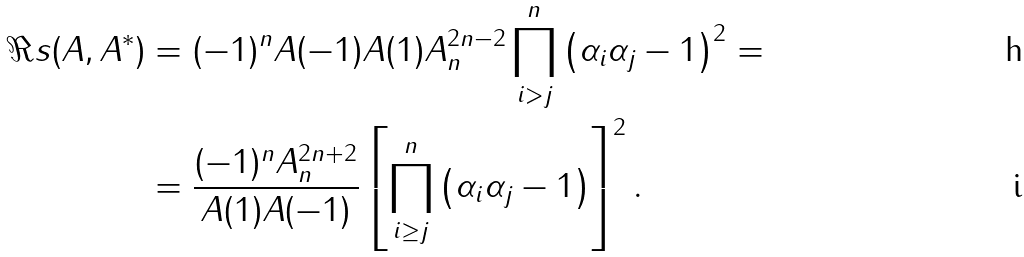<formula> <loc_0><loc_0><loc_500><loc_500>\Re s ( A , A ^ { * } ) & = ( - 1 ) ^ { n } A ( - 1 ) A ( 1 ) A _ { n } ^ { 2 n - 2 } \prod _ { i > j } ^ { n } \left ( \alpha _ { i } \alpha _ { j } - 1 \right ) ^ { 2 } = \\ & = \frac { ( - 1 ) ^ { n } A _ { n } ^ { 2 n + 2 } } { A ( 1 ) A ( - 1 ) } \left [ \prod _ { i \geq j } ^ { n } \left ( \alpha _ { i } \alpha _ { j } - 1 \right ) \right ] ^ { 2 } .</formula> 